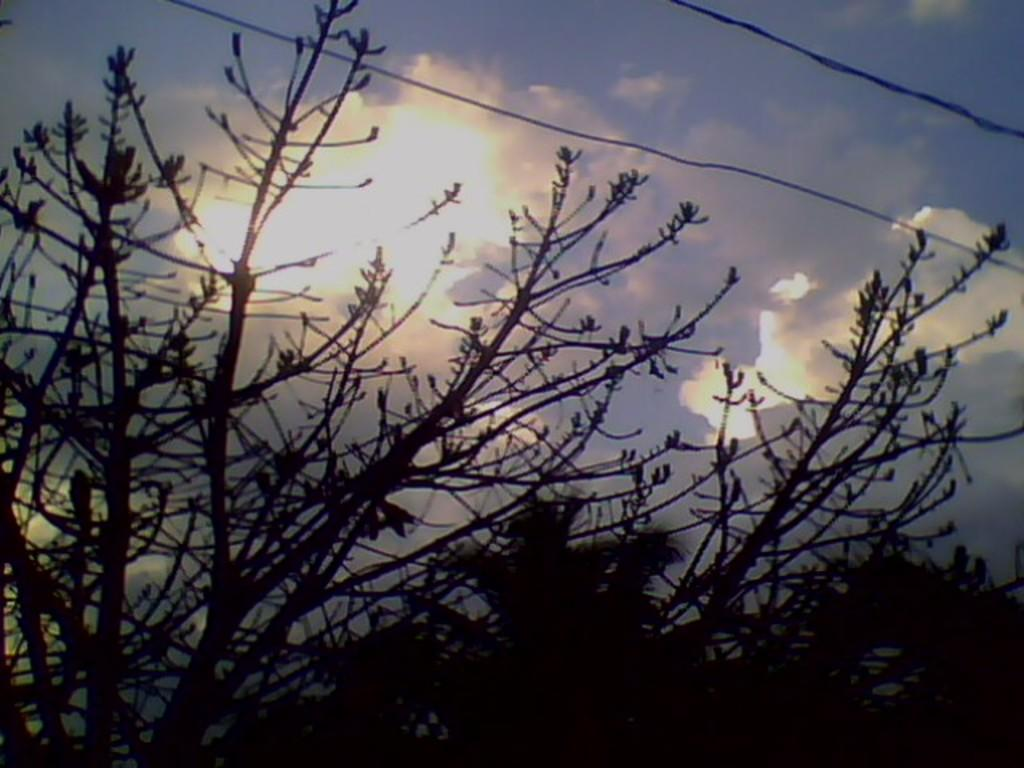What type of living organisms can be seen in the image? Plants can be seen in the image. What else is present in the image besides plants? There are wires in the image. What can be seen in the background of the image? The sky is visible in the background of the image. What is the condition of the sky in the image? Clouds are present in the sky. Can you see the spy hiding behind the plants in the image? There is no spy present in the image; it only features plants and wires. 